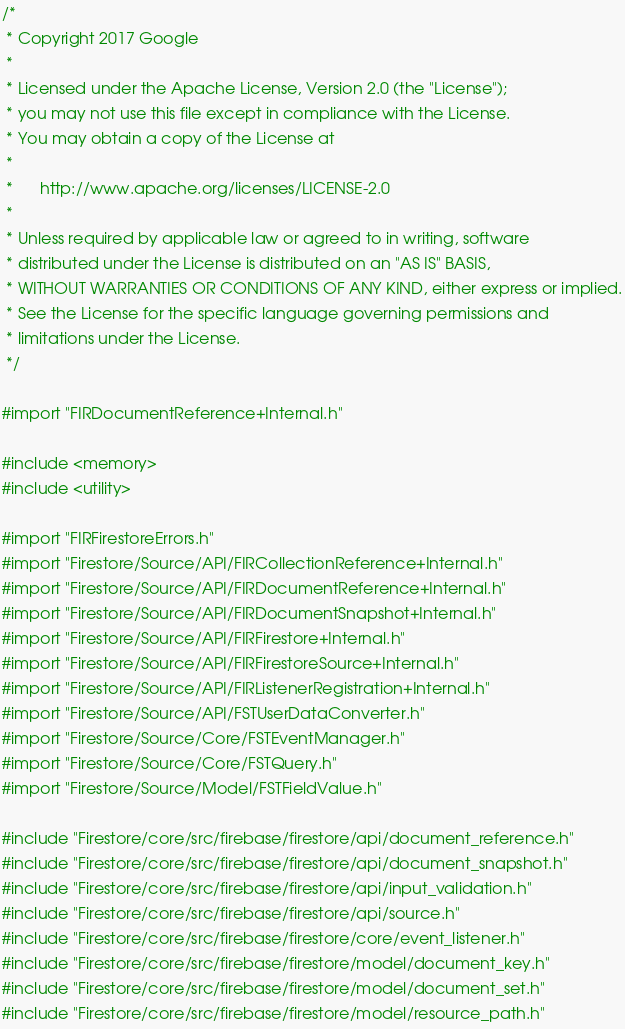Convert code to text. <code><loc_0><loc_0><loc_500><loc_500><_ObjectiveC_>/*
 * Copyright 2017 Google
 *
 * Licensed under the Apache License, Version 2.0 (the "License");
 * you may not use this file except in compliance with the License.
 * You may obtain a copy of the License at
 *
 *      http://www.apache.org/licenses/LICENSE-2.0
 *
 * Unless required by applicable law or agreed to in writing, software
 * distributed under the License is distributed on an "AS IS" BASIS,
 * WITHOUT WARRANTIES OR CONDITIONS OF ANY KIND, either express or implied.
 * See the License for the specific language governing permissions and
 * limitations under the License.
 */

#import "FIRDocumentReference+Internal.h"

#include <memory>
#include <utility>

#import "FIRFirestoreErrors.h"
#import "Firestore/Source/API/FIRCollectionReference+Internal.h"
#import "Firestore/Source/API/FIRDocumentReference+Internal.h"
#import "Firestore/Source/API/FIRDocumentSnapshot+Internal.h"
#import "Firestore/Source/API/FIRFirestore+Internal.h"
#import "Firestore/Source/API/FIRFirestoreSource+Internal.h"
#import "Firestore/Source/API/FIRListenerRegistration+Internal.h"
#import "Firestore/Source/API/FSTUserDataConverter.h"
#import "Firestore/Source/Core/FSTEventManager.h"
#import "Firestore/Source/Core/FSTQuery.h"
#import "Firestore/Source/Model/FSTFieldValue.h"

#include "Firestore/core/src/firebase/firestore/api/document_reference.h"
#include "Firestore/core/src/firebase/firestore/api/document_snapshot.h"
#include "Firestore/core/src/firebase/firestore/api/input_validation.h"
#include "Firestore/core/src/firebase/firestore/api/source.h"
#include "Firestore/core/src/firebase/firestore/core/event_listener.h"
#include "Firestore/core/src/firebase/firestore/model/document_key.h"
#include "Firestore/core/src/firebase/firestore/model/document_set.h"
#include "Firestore/core/src/firebase/firestore/model/resource_path.h"</code> 